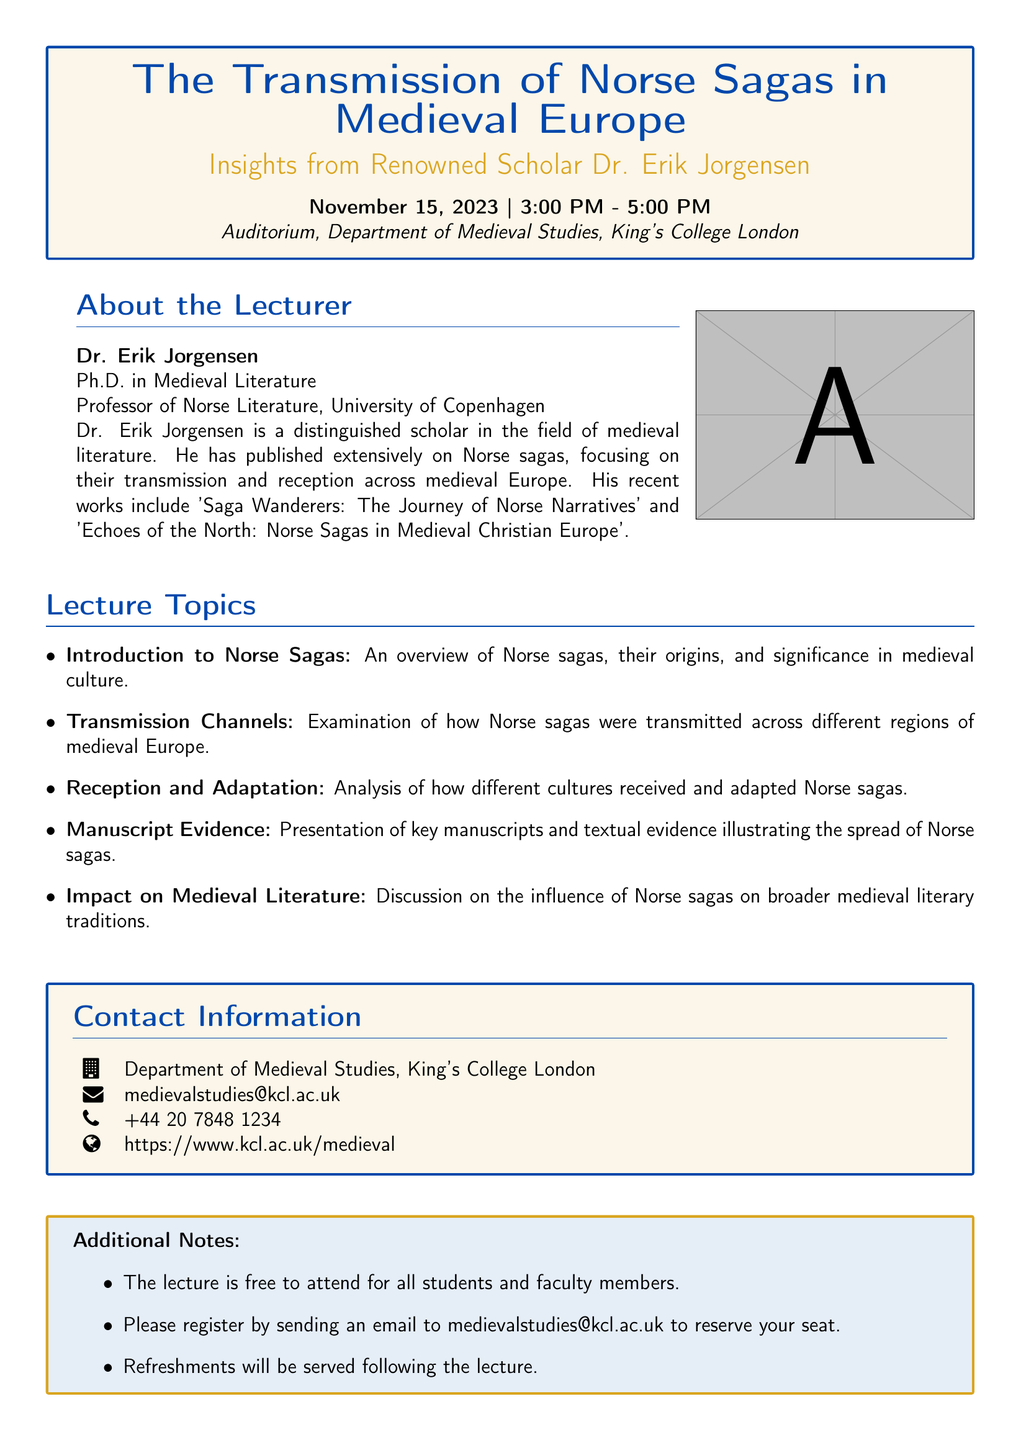What is the date of the lecture? The date of the lecture is specified in the event details section of the document.
Answer: November 15, 2023 Who is the lecturer? The lecturer's name is provided in the document under the About the Lecturer section.
Answer: Dr. Erik Jorgensen What is the venue of the lecture? The venue is listed as the location for the lecture within the event details.
Answer: Auditorium, Department of Medieval Studies, King's College London What topics will be covered in the lecture? The lecture topics are detailed in a list within the document.
Answer: Overview of Norse sagas What kind of refreshments will be served after the lecture? The document indicates that refreshments will be served without specifying the type.
Answer: Refreshments Is registration required to attend the lecture? The document contains information about the registration process for attendees.
Answer: Yes What is Dr. Erik Jorgensen's title? Dr. Jorgensen's title is mentioned in the About the Lecturer section.
Answer: Professor of Norse Literature What is the time range for the lecture? The time range is provided in the event details section of the document.
Answer: 3:00 PM - 5:00 PM What contact method is provided for registration? The contact method for registration is listed in the contact information section.
Answer: Email 